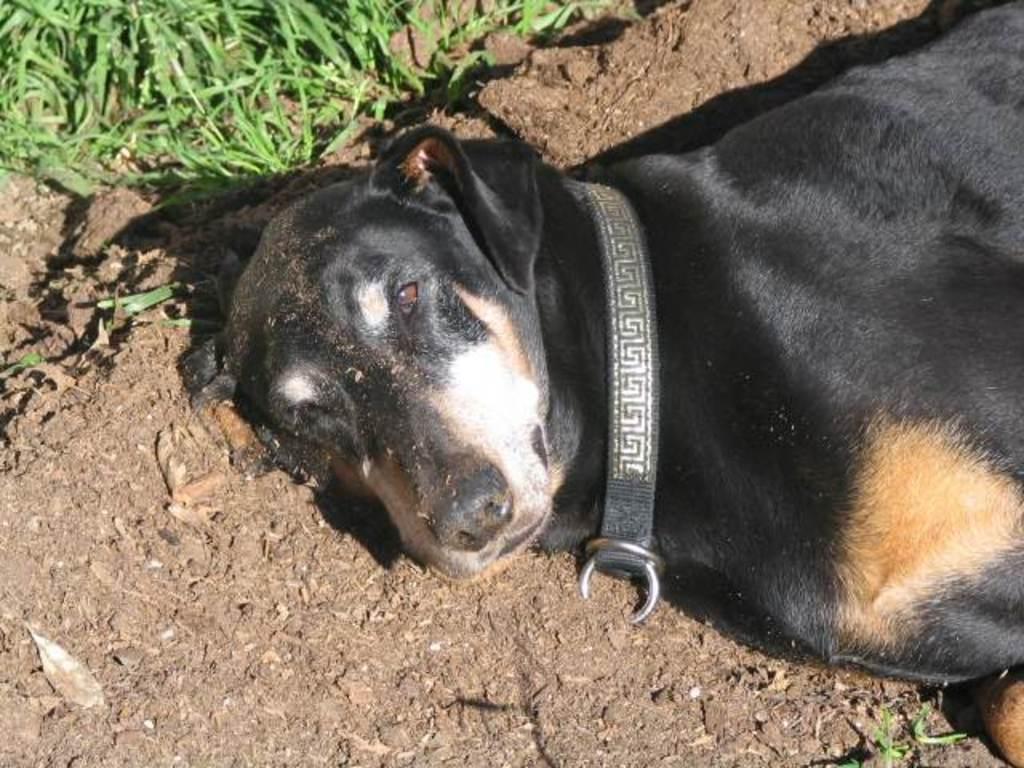Can you describe this image briefly? In this picture we can see a black dog lying on the ground and in the background we can see the grass. 